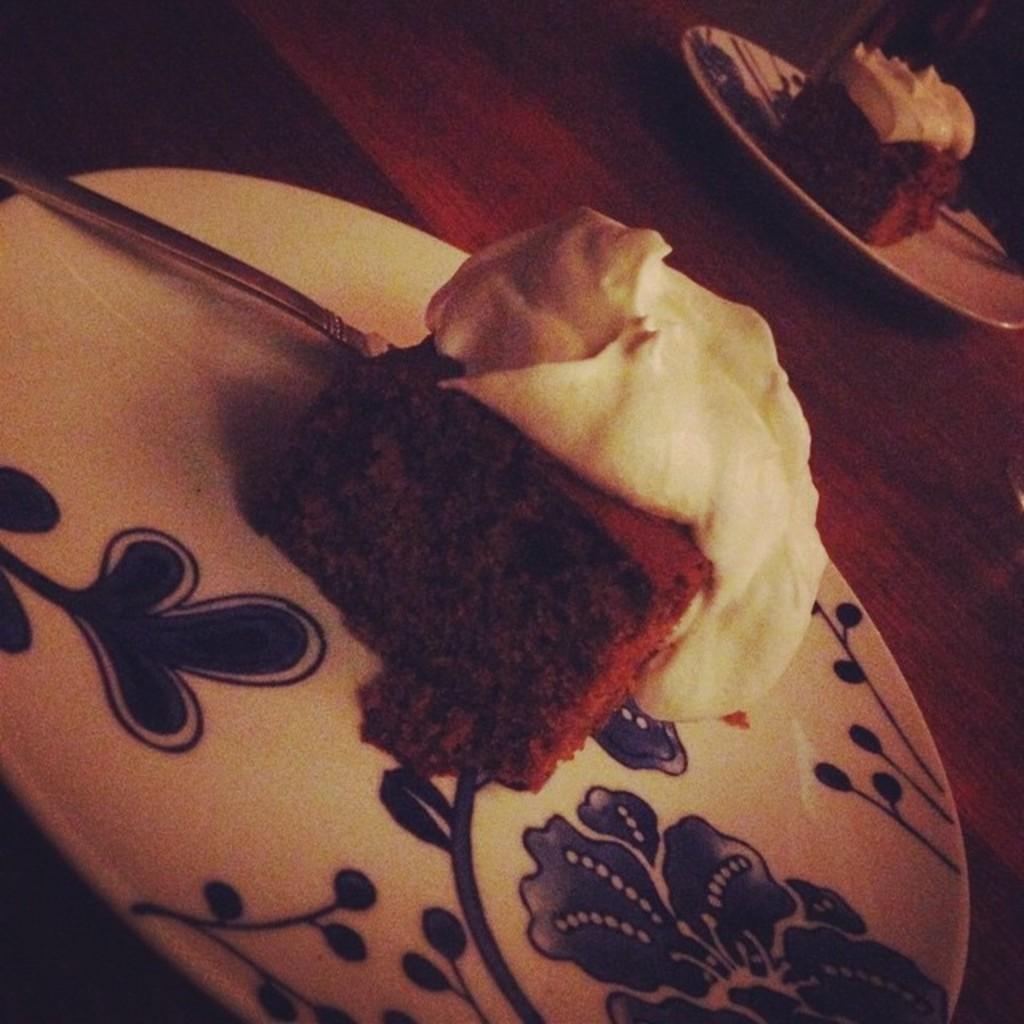What piece of furniture is present in the image? There is a table in the image. What items are placed on the table? There are plates and spoons on the table. What type of food is visible on the table? There are cakes with creams on the table. Where is the hydrant located in the image? There is no hydrant present in the image. What type of pot is used to prepare the cakes with creams in the image? The provided facts do not mention a pot being used to prepare the cakes with creams. 